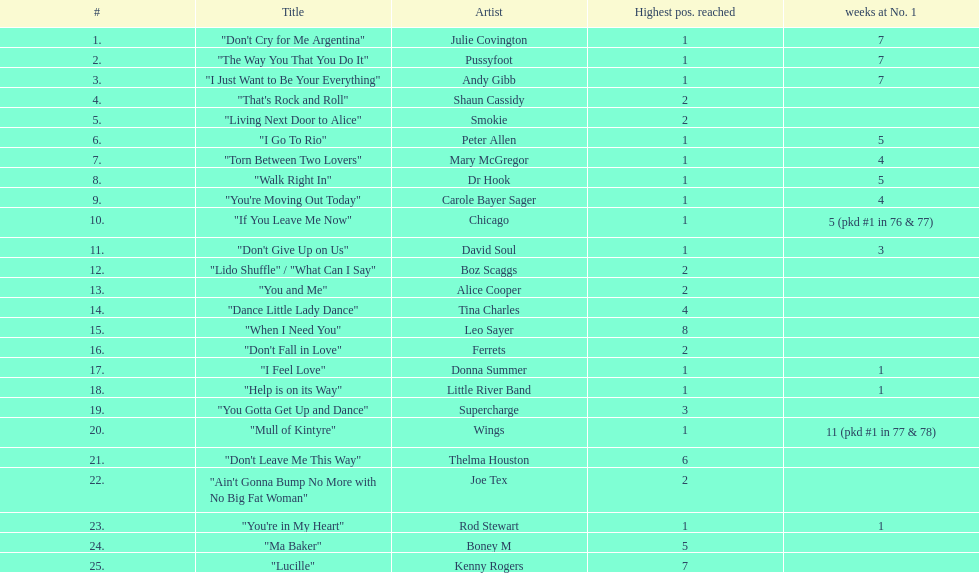In 1977, how many weeks did julie covington's single "don't cry for me argentina" remain at the top position? 7. 